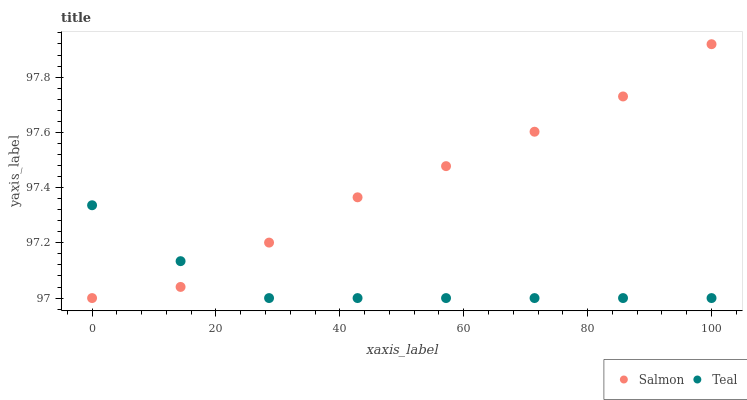Does Teal have the minimum area under the curve?
Answer yes or no. Yes. Does Salmon have the maximum area under the curve?
Answer yes or no. Yes. Does Teal have the maximum area under the curve?
Answer yes or no. No. Is Teal the smoothest?
Answer yes or no. Yes. Is Salmon the roughest?
Answer yes or no. Yes. Is Teal the roughest?
Answer yes or no. No. Does Salmon have the lowest value?
Answer yes or no. Yes. Does Salmon have the highest value?
Answer yes or no. Yes. Does Teal have the highest value?
Answer yes or no. No. Does Teal intersect Salmon?
Answer yes or no. Yes. Is Teal less than Salmon?
Answer yes or no. No. Is Teal greater than Salmon?
Answer yes or no. No. 